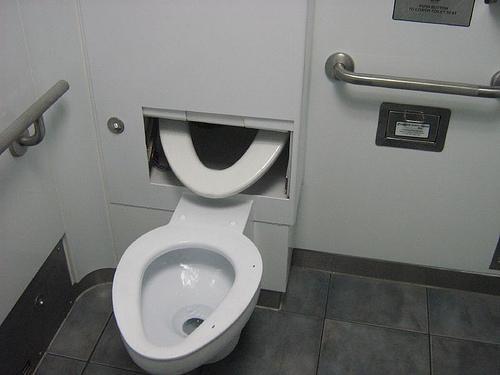How many toilets are there?
Give a very brief answer. 1. 